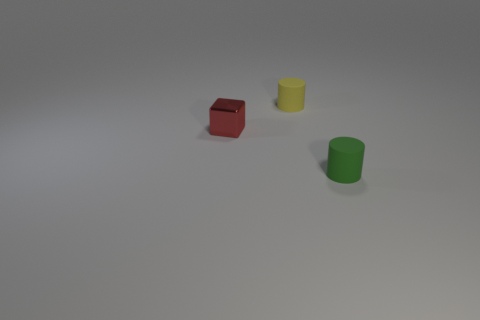Do the small yellow cylinder and the tiny green cylinder have the same material?
Make the answer very short. Yes. What number of green matte cylinders are behind the tiny cylinder that is on the right side of the tiny cylinder that is behind the tiny metallic block?
Your answer should be very brief. 0. There is a small matte thing in front of the yellow rubber thing; what is its shape?
Offer a terse response. Cylinder. What number of other objects are the same material as the small green thing?
Keep it short and to the point. 1. Is the number of red cubes that are to the right of the small red thing less than the number of small yellow cylinders to the left of the yellow rubber object?
Offer a very short reply. No. There is another rubber thing that is the same shape as the tiny yellow matte thing; what is its color?
Offer a terse response. Green. Is the size of the matte cylinder that is behind the red thing the same as the block?
Make the answer very short. Yes. Is the number of things that are in front of the small yellow matte cylinder less than the number of cylinders?
Your answer should be very brief. No. Is there anything else that is the same size as the yellow matte cylinder?
Provide a short and direct response. Yes. What is the size of the cylinder behind the tiny cylinder that is in front of the small yellow object?
Keep it short and to the point. Small. 